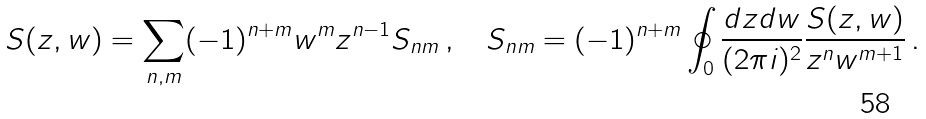Convert formula to latex. <formula><loc_0><loc_0><loc_500><loc_500>S ( z , w ) = \sum _ { n , m } ( - 1 ) ^ { n + m } w ^ { m } z ^ { n - 1 } S _ { n m } \, , \quad S _ { n m } = ( - 1 ) ^ { n + m } \oint _ { 0 } \frac { d z d w } { ( 2 \pi i ) ^ { 2 } } \frac { S ( z , w ) } { z ^ { n } w ^ { m + 1 } } \, .</formula> 